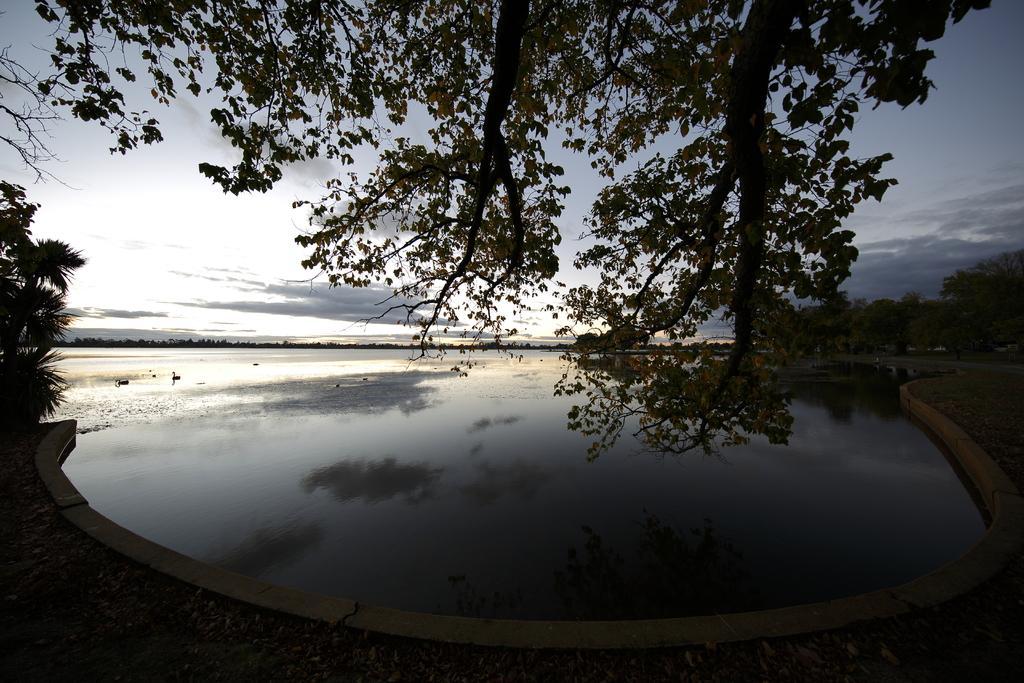In one or two sentences, can you explain what this image depicts? In this picture I can see trees, water and the sky in the background. 